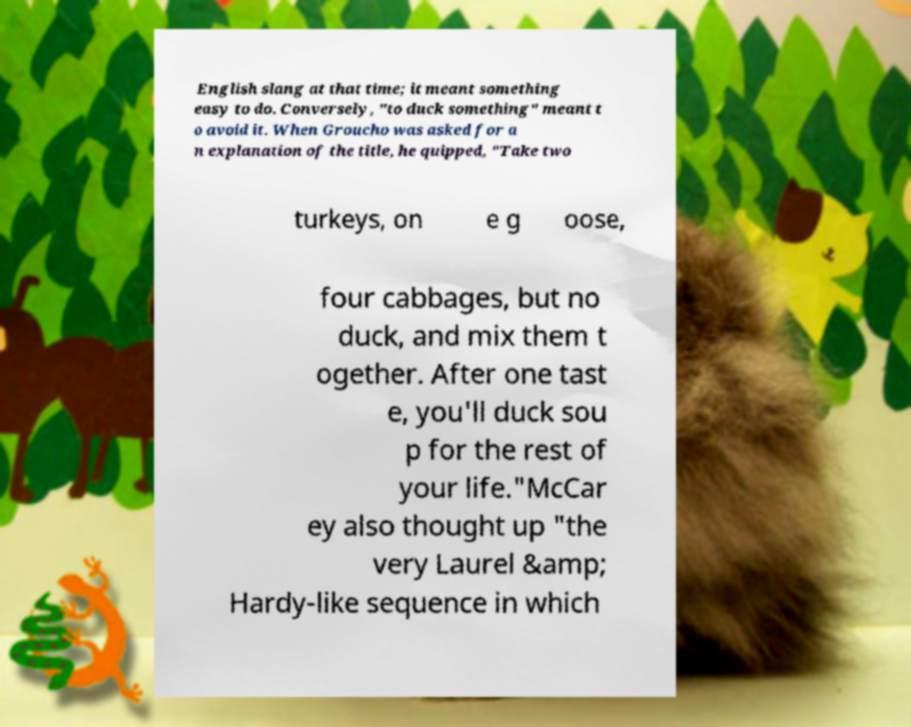Please read and relay the text visible in this image. What does it say? English slang at that time; it meant something easy to do. Conversely, "to duck something" meant t o avoid it. When Groucho was asked for a n explanation of the title, he quipped, "Take two turkeys, on e g oose, four cabbages, but no duck, and mix them t ogether. After one tast e, you'll duck sou p for the rest of your life."McCar ey also thought up "the very Laurel &amp; Hardy-like sequence in which 